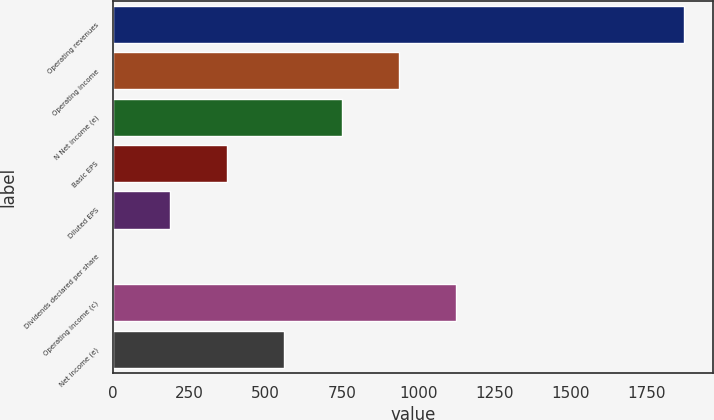Convert chart to OTSL. <chart><loc_0><loc_0><loc_500><loc_500><bar_chart><fcel>Operating revenues<fcel>Operating income<fcel>N Net income (e)<fcel>Basic EPS<fcel>Diluted EPS<fcel>Dividends declared per share<fcel>Operating income (c)<fcel>Net income (e)<nl><fcel>1872<fcel>936.21<fcel>749.05<fcel>374.73<fcel>187.57<fcel>0.41<fcel>1123.37<fcel>561.89<nl></chart> 